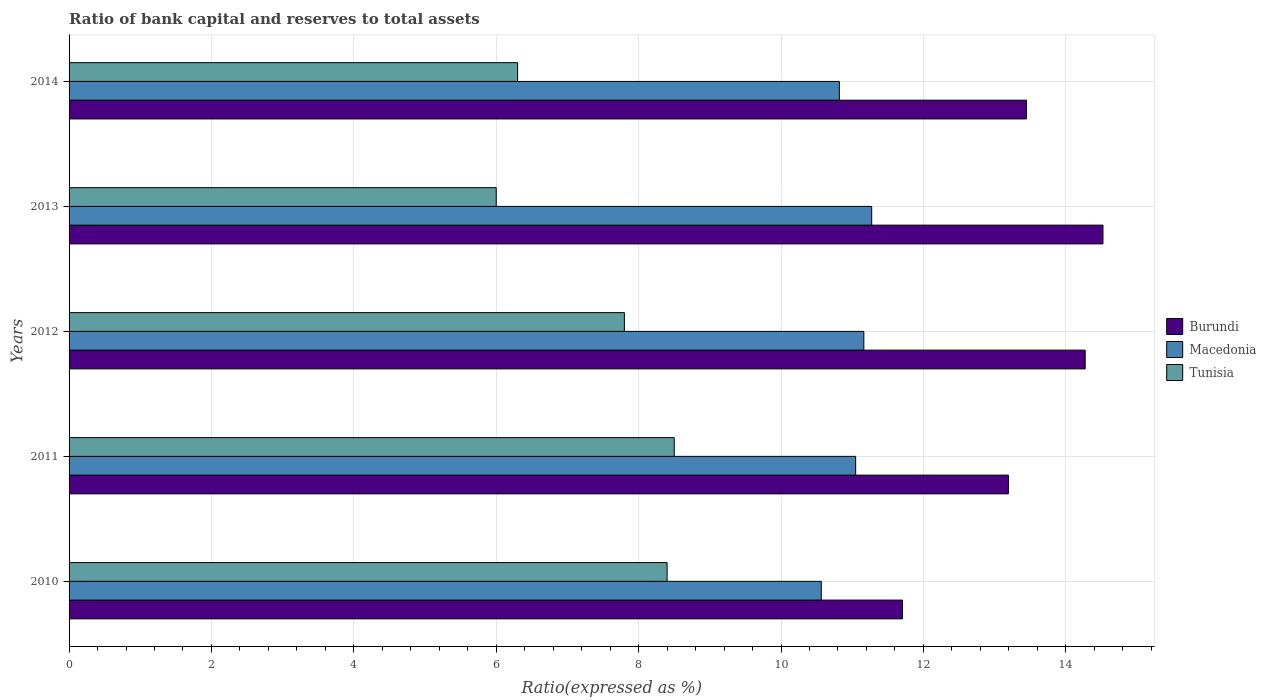How many groups of bars are there?
Provide a succinct answer. 5. Are the number of bars per tick equal to the number of legend labels?
Offer a very short reply. Yes. Are the number of bars on each tick of the Y-axis equal?
Make the answer very short. Yes. How many bars are there on the 2nd tick from the top?
Ensure brevity in your answer.  3. How many bars are there on the 3rd tick from the bottom?
Your answer should be very brief. 3. In how many cases, is the number of bars for a given year not equal to the number of legend labels?
Keep it short and to the point. 0. What is the ratio of bank capital and reserves to total assets in Macedonia in 2013?
Offer a very short reply. 11.27. Across all years, what is the maximum ratio of bank capital and reserves to total assets in Macedonia?
Provide a succinct answer. 11.27. Across all years, what is the minimum ratio of bank capital and reserves to total assets in Burundi?
Your answer should be very brief. 11.71. In which year was the ratio of bank capital and reserves to total assets in Macedonia maximum?
Provide a short and direct response. 2013. What is the total ratio of bank capital and reserves to total assets in Tunisia in the graph?
Your answer should be compact. 37. What is the difference between the ratio of bank capital and reserves to total assets in Macedonia in 2010 and that in 2014?
Give a very brief answer. -0.25. What is the difference between the ratio of bank capital and reserves to total assets in Burundi in 2010 and the ratio of bank capital and reserves to total assets in Macedonia in 2012?
Give a very brief answer. 0.54. What is the average ratio of bank capital and reserves to total assets in Burundi per year?
Make the answer very short. 13.43. In the year 2013, what is the difference between the ratio of bank capital and reserves to total assets in Macedonia and ratio of bank capital and reserves to total assets in Burundi?
Your answer should be compact. -3.25. In how many years, is the ratio of bank capital and reserves to total assets in Burundi greater than 12 %?
Your answer should be very brief. 4. What is the ratio of the ratio of bank capital and reserves to total assets in Burundi in 2010 to that in 2012?
Ensure brevity in your answer.  0.82. Is the ratio of bank capital and reserves to total assets in Macedonia in 2011 less than that in 2012?
Ensure brevity in your answer.  Yes. What is the difference between the highest and the second highest ratio of bank capital and reserves to total assets in Tunisia?
Give a very brief answer. 0.1. What is the difference between the highest and the lowest ratio of bank capital and reserves to total assets in Macedonia?
Your response must be concise. 0.71. Is the sum of the ratio of bank capital and reserves to total assets in Burundi in 2012 and 2014 greater than the maximum ratio of bank capital and reserves to total assets in Tunisia across all years?
Provide a succinct answer. Yes. What does the 2nd bar from the top in 2013 represents?
Keep it short and to the point. Macedonia. What does the 2nd bar from the bottom in 2013 represents?
Provide a succinct answer. Macedonia. Is it the case that in every year, the sum of the ratio of bank capital and reserves to total assets in Burundi and ratio of bank capital and reserves to total assets in Macedonia is greater than the ratio of bank capital and reserves to total assets in Tunisia?
Your answer should be compact. Yes. How many years are there in the graph?
Make the answer very short. 5. Are the values on the major ticks of X-axis written in scientific E-notation?
Offer a very short reply. No. How are the legend labels stacked?
Offer a terse response. Vertical. What is the title of the graph?
Offer a very short reply. Ratio of bank capital and reserves to total assets. Does "Croatia" appear as one of the legend labels in the graph?
Your answer should be compact. No. What is the label or title of the X-axis?
Offer a very short reply. Ratio(expressed as %). What is the Ratio(expressed as %) in Burundi in 2010?
Keep it short and to the point. 11.71. What is the Ratio(expressed as %) of Macedonia in 2010?
Your answer should be compact. 10.57. What is the Ratio(expressed as %) in Burundi in 2011?
Give a very brief answer. 13.19. What is the Ratio(expressed as %) in Macedonia in 2011?
Make the answer very short. 11.05. What is the Ratio(expressed as %) of Tunisia in 2011?
Provide a succinct answer. 8.5. What is the Ratio(expressed as %) of Burundi in 2012?
Keep it short and to the point. 14.27. What is the Ratio(expressed as %) of Macedonia in 2012?
Keep it short and to the point. 11.16. What is the Ratio(expressed as %) in Tunisia in 2012?
Make the answer very short. 7.8. What is the Ratio(expressed as %) of Burundi in 2013?
Ensure brevity in your answer.  14.52. What is the Ratio(expressed as %) in Macedonia in 2013?
Ensure brevity in your answer.  11.27. What is the Ratio(expressed as %) in Burundi in 2014?
Keep it short and to the point. 13.45. What is the Ratio(expressed as %) of Macedonia in 2014?
Give a very brief answer. 10.82. What is the Ratio(expressed as %) in Tunisia in 2014?
Your answer should be compact. 6.3. Across all years, what is the maximum Ratio(expressed as %) in Burundi?
Give a very brief answer. 14.52. Across all years, what is the maximum Ratio(expressed as %) of Macedonia?
Make the answer very short. 11.27. Across all years, what is the maximum Ratio(expressed as %) of Tunisia?
Keep it short and to the point. 8.5. Across all years, what is the minimum Ratio(expressed as %) in Burundi?
Make the answer very short. 11.71. Across all years, what is the minimum Ratio(expressed as %) in Macedonia?
Make the answer very short. 10.57. Across all years, what is the minimum Ratio(expressed as %) in Tunisia?
Offer a terse response. 6. What is the total Ratio(expressed as %) of Burundi in the graph?
Your response must be concise. 67.14. What is the total Ratio(expressed as %) of Macedonia in the graph?
Make the answer very short. 54.87. What is the difference between the Ratio(expressed as %) of Burundi in 2010 and that in 2011?
Give a very brief answer. -1.49. What is the difference between the Ratio(expressed as %) in Macedonia in 2010 and that in 2011?
Your answer should be very brief. -0.48. What is the difference between the Ratio(expressed as %) of Burundi in 2010 and that in 2012?
Make the answer very short. -2.57. What is the difference between the Ratio(expressed as %) in Macedonia in 2010 and that in 2012?
Offer a terse response. -0.6. What is the difference between the Ratio(expressed as %) in Burundi in 2010 and that in 2013?
Your response must be concise. -2.82. What is the difference between the Ratio(expressed as %) of Macedonia in 2010 and that in 2013?
Make the answer very short. -0.71. What is the difference between the Ratio(expressed as %) of Tunisia in 2010 and that in 2013?
Provide a short and direct response. 2.4. What is the difference between the Ratio(expressed as %) of Burundi in 2010 and that in 2014?
Your response must be concise. -1.74. What is the difference between the Ratio(expressed as %) in Macedonia in 2010 and that in 2014?
Make the answer very short. -0.25. What is the difference between the Ratio(expressed as %) in Tunisia in 2010 and that in 2014?
Offer a terse response. 2.1. What is the difference between the Ratio(expressed as %) in Burundi in 2011 and that in 2012?
Offer a terse response. -1.08. What is the difference between the Ratio(expressed as %) in Macedonia in 2011 and that in 2012?
Make the answer very short. -0.12. What is the difference between the Ratio(expressed as %) in Burundi in 2011 and that in 2013?
Offer a very short reply. -1.33. What is the difference between the Ratio(expressed as %) in Macedonia in 2011 and that in 2013?
Your response must be concise. -0.23. What is the difference between the Ratio(expressed as %) of Tunisia in 2011 and that in 2013?
Keep it short and to the point. 2.5. What is the difference between the Ratio(expressed as %) of Burundi in 2011 and that in 2014?
Provide a short and direct response. -0.25. What is the difference between the Ratio(expressed as %) of Macedonia in 2011 and that in 2014?
Provide a succinct answer. 0.23. What is the difference between the Ratio(expressed as %) in Burundi in 2012 and that in 2013?
Your answer should be compact. -0.25. What is the difference between the Ratio(expressed as %) of Macedonia in 2012 and that in 2013?
Your answer should be compact. -0.11. What is the difference between the Ratio(expressed as %) in Burundi in 2012 and that in 2014?
Your response must be concise. 0.82. What is the difference between the Ratio(expressed as %) of Macedonia in 2012 and that in 2014?
Provide a succinct answer. 0.34. What is the difference between the Ratio(expressed as %) in Burundi in 2013 and that in 2014?
Make the answer very short. 1.07. What is the difference between the Ratio(expressed as %) in Macedonia in 2013 and that in 2014?
Your answer should be very brief. 0.45. What is the difference between the Ratio(expressed as %) in Burundi in 2010 and the Ratio(expressed as %) in Macedonia in 2011?
Offer a terse response. 0.66. What is the difference between the Ratio(expressed as %) in Burundi in 2010 and the Ratio(expressed as %) in Tunisia in 2011?
Provide a succinct answer. 3.21. What is the difference between the Ratio(expressed as %) in Macedonia in 2010 and the Ratio(expressed as %) in Tunisia in 2011?
Your response must be concise. 2.07. What is the difference between the Ratio(expressed as %) in Burundi in 2010 and the Ratio(expressed as %) in Macedonia in 2012?
Make the answer very short. 0.54. What is the difference between the Ratio(expressed as %) in Burundi in 2010 and the Ratio(expressed as %) in Tunisia in 2012?
Provide a short and direct response. 3.91. What is the difference between the Ratio(expressed as %) in Macedonia in 2010 and the Ratio(expressed as %) in Tunisia in 2012?
Make the answer very short. 2.77. What is the difference between the Ratio(expressed as %) in Burundi in 2010 and the Ratio(expressed as %) in Macedonia in 2013?
Keep it short and to the point. 0.43. What is the difference between the Ratio(expressed as %) of Burundi in 2010 and the Ratio(expressed as %) of Tunisia in 2013?
Offer a terse response. 5.71. What is the difference between the Ratio(expressed as %) in Macedonia in 2010 and the Ratio(expressed as %) in Tunisia in 2013?
Your response must be concise. 4.57. What is the difference between the Ratio(expressed as %) of Burundi in 2010 and the Ratio(expressed as %) of Macedonia in 2014?
Offer a very short reply. 0.89. What is the difference between the Ratio(expressed as %) of Burundi in 2010 and the Ratio(expressed as %) of Tunisia in 2014?
Make the answer very short. 5.41. What is the difference between the Ratio(expressed as %) of Macedonia in 2010 and the Ratio(expressed as %) of Tunisia in 2014?
Your answer should be very brief. 4.27. What is the difference between the Ratio(expressed as %) in Burundi in 2011 and the Ratio(expressed as %) in Macedonia in 2012?
Offer a terse response. 2.03. What is the difference between the Ratio(expressed as %) in Burundi in 2011 and the Ratio(expressed as %) in Tunisia in 2012?
Make the answer very short. 5.39. What is the difference between the Ratio(expressed as %) of Macedonia in 2011 and the Ratio(expressed as %) of Tunisia in 2012?
Provide a short and direct response. 3.25. What is the difference between the Ratio(expressed as %) in Burundi in 2011 and the Ratio(expressed as %) in Macedonia in 2013?
Offer a terse response. 1.92. What is the difference between the Ratio(expressed as %) of Burundi in 2011 and the Ratio(expressed as %) of Tunisia in 2013?
Offer a terse response. 7.19. What is the difference between the Ratio(expressed as %) in Macedonia in 2011 and the Ratio(expressed as %) in Tunisia in 2013?
Offer a very short reply. 5.05. What is the difference between the Ratio(expressed as %) in Burundi in 2011 and the Ratio(expressed as %) in Macedonia in 2014?
Your answer should be very brief. 2.37. What is the difference between the Ratio(expressed as %) in Burundi in 2011 and the Ratio(expressed as %) in Tunisia in 2014?
Provide a short and direct response. 6.89. What is the difference between the Ratio(expressed as %) of Macedonia in 2011 and the Ratio(expressed as %) of Tunisia in 2014?
Offer a very short reply. 4.75. What is the difference between the Ratio(expressed as %) of Burundi in 2012 and the Ratio(expressed as %) of Macedonia in 2013?
Provide a short and direct response. 3. What is the difference between the Ratio(expressed as %) of Burundi in 2012 and the Ratio(expressed as %) of Tunisia in 2013?
Provide a succinct answer. 8.27. What is the difference between the Ratio(expressed as %) in Macedonia in 2012 and the Ratio(expressed as %) in Tunisia in 2013?
Provide a succinct answer. 5.16. What is the difference between the Ratio(expressed as %) in Burundi in 2012 and the Ratio(expressed as %) in Macedonia in 2014?
Your answer should be compact. 3.45. What is the difference between the Ratio(expressed as %) in Burundi in 2012 and the Ratio(expressed as %) in Tunisia in 2014?
Your answer should be compact. 7.97. What is the difference between the Ratio(expressed as %) in Macedonia in 2012 and the Ratio(expressed as %) in Tunisia in 2014?
Ensure brevity in your answer.  4.86. What is the difference between the Ratio(expressed as %) in Burundi in 2013 and the Ratio(expressed as %) in Macedonia in 2014?
Ensure brevity in your answer.  3.7. What is the difference between the Ratio(expressed as %) in Burundi in 2013 and the Ratio(expressed as %) in Tunisia in 2014?
Your answer should be compact. 8.22. What is the difference between the Ratio(expressed as %) in Macedonia in 2013 and the Ratio(expressed as %) in Tunisia in 2014?
Ensure brevity in your answer.  4.97. What is the average Ratio(expressed as %) of Burundi per year?
Ensure brevity in your answer.  13.43. What is the average Ratio(expressed as %) in Macedonia per year?
Keep it short and to the point. 10.97. In the year 2010, what is the difference between the Ratio(expressed as %) in Burundi and Ratio(expressed as %) in Macedonia?
Provide a short and direct response. 1.14. In the year 2010, what is the difference between the Ratio(expressed as %) in Burundi and Ratio(expressed as %) in Tunisia?
Give a very brief answer. 3.31. In the year 2010, what is the difference between the Ratio(expressed as %) of Macedonia and Ratio(expressed as %) of Tunisia?
Your response must be concise. 2.17. In the year 2011, what is the difference between the Ratio(expressed as %) in Burundi and Ratio(expressed as %) in Macedonia?
Your answer should be compact. 2.15. In the year 2011, what is the difference between the Ratio(expressed as %) of Burundi and Ratio(expressed as %) of Tunisia?
Ensure brevity in your answer.  4.69. In the year 2011, what is the difference between the Ratio(expressed as %) of Macedonia and Ratio(expressed as %) of Tunisia?
Provide a short and direct response. 2.55. In the year 2012, what is the difference between the Ratio(expressed as %) in Burundi and Ratio(expressed as %) in Macedonia?
Keep it short and to the point. 3.11. In the year 2012, what is the difference between the Ratio(expressed as %) of Burundi and Ratio(expressed as %) of Tunisia?
Give a very brief answer. 6.47. In the year 2012, what is the difference between the Ratio(expressed as %) in Macedonia and Ratio(expressed as %) in Tunisia?
Offer a terse response. 3.36. In the year 2013, what is the difference between the Ratio(expressed as %) in Burundi and Ratio(expressed as %) in Macedonia?
Offer a terse response. 3.25. In the year 2013, what is the difference between the Ratio(expressed as %) in Burundi and Ratio(expressed as %) in Tunisia?
Provide a short and direct response. 8.52. In the year 2013, what is the difference between the Ratio(expressed as %) in Macedonia and Ratio(expressed as %) in Tunisia?
Your answer should be very brief. 5.27. In the year 2014, what is the difference between the Ratio(expressed as %) of Burundi and Ratio(expressed as %) of Macedonia?
Make the answer very short. 2.63. In the year 2014, what is the difference between the Ratio(expressed as %) of Burundi and Ratio(expressed as %) of Tunisia?
Your response must be concise. 7.15. In the year 2014, what is the difference between the Ratio(expressed as %) in Macedonia and Ratio(expressed as %) in Tunisia?
Make the answer very short. 4.52. What is the ratio of the Ratio(expressed as %) of Burundi in 2010 to that in 2011?
Keep it short and to the point. 0.89. What is the ratio of the Ratio(expressed as %) in Macedonia in 2010 to that in 2011?
Offer a terse response. 0.96. What is the ratio of the Ratio(expressed as %) of Tunisia in 2010 to that in 2011?
Offer a terse response. 0.99. What is the ratio of the Ratio(expressed as %) in Burundi in 2010 to that in 2012?
Provide a succinct answer. 0.82. What is the ratio of the Ratio(expressed as %) of Macedonia in 2010 to that in 2012?
Offer a terse response. 0.95. What is the ratio of the Ratio(expressed as %) of Burundi in 2010 to that in 2013?
Provide a succinct answer. 0.81. What is the ratio of the Ratio(expressed as %) of Macedonia in 2010 to that in 2013?
Provide a short and direct response. 0.94. What is the ratio of the Ratio(expressed as %) in Burundi in 2010 to that in 2014?
Ensure brevity in your answer.  0.87. What is the ratio of the Ratio(expressed as %) in Macedonia in 2010 to that in 2014?
Your response must be concise. 0.98. What is the ratio of the Ratio(expressed as %) of Burundi in 2011 to that in 2012?
Provide a short and direct response. 0.92. What is the ratio of the Ratio(expressed as %) in Tunisia in 2011 to that in 2012?
Your response must be concise. 1.09. What is the ratio of the Ratio(expressed as %) of Burundi in 2011 to that in 2013?
Make the answer very short. 0.91. What is the ratio of the Ratio(expressed as %) in Tunisia in 2011 to that in 2013?
Offer a very short reply. 1.42. What is the ratio of the Ratio(expressed as %) in Burundi in 2011 to that in 2014?
Give a very brief answer. 0.98. What is the ratio of the Ratio(expressed as %) of Macedonia in 2011 to that in 2014?
Give a very brief answer. 1.02. What is the ratio of the Ratio(expressed as %) in Tunisia in 2011 to that in 2014?
Provide a succinct answer. 1.35. What is the ratio of the Ratio(expressed as %) of Burundi in 2012 to that in 2013?
Provide a succinct answer. 0.98. What is the ratio of the Ratio(expressed as %) in Macedonia in 2012 to that in 2013?
Keep it short and to the point. 0.99. What is the ratio of the Ratio(expressed as %) of Tunisia in 2012 to that in 2013?
Offer a very short reply. 1.3. What is the ratio of the Ratio(expressed as %) in Burundi in 2012 to that in 2014?
Provide a succinct answer. 1.06. What is the ratio of the Ratio(expressed as %) of Macedonia in 2012 to that in 2014?
Provide a succinct answer. 1.03. What is the ratio of the Ratio(expressed as %) in Tunisia in 2012 to that in 2014?
Your answer should be compact. 1.24. What is the ratio of the Ratio(expressed as %) in Burundi in 2013 to that in 2014?
Your response must be concise. 1.08. What is the ratio of the Ratio(expressed as %) of Macedonia in 2013 to that in 2014?
Provide a succinct answer. 1.04. What is the ratio of the Ratio(expressed as %) in Tunisia in 2013 to that in 2014?
Your response must be concise. 0.95. What is the difference between the highest and the second highest Ratio(expressed as %) of Burundi?
Offer a very short reply. 0.25. What is the difference between the highest and the second highest Ratio(expressed as %) in Macedonia?
Ensure brevity in your answer.  0.11. What is the difference between the highest and the lowest Ratio(expressed as %) of Burundi?
Your response must be concise. 2.82. What is the difference between the highest and the lowest Ratio(expressed as %) in Macedonia?
Your answer should be compact. 0.71. What is the difference between the highest and the lowest Ratio(expressed as %) in Tunisia?
Give a very brief answer. 2.5. 